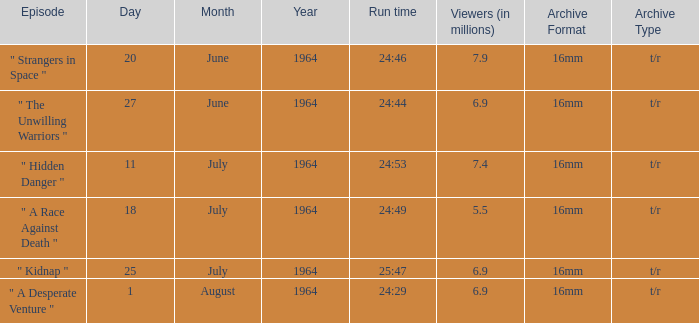Would you mind parsing the complete table? {'header': ['Episode', 'Day', 'Month', 'Year', 'Run time', 'Viewers (in millions)', 'Archive Format', 'Archive Type'], 'rows': [['" Strangers in Space "', '20', 'June', '1964', '24:46', '7.9', '16mm', 't/r'], ['" The Unwilling Warriors "', '27', 'June', '1964', '24:44', '6.9', '16mm', 't/r'], ['" Hidden Danger "', '11', 'July', '1964', '24:53', '7.4', '16mm', 't/r'], ['" A Race Against Death "', '18', 'July', '1964', '24:49', '5.5', '16mm', 't/r'], ['" Kidnap "', '25', 'July', '1964', '25:47', '6.9', '16mm', 't/r'], ['" A Desperate Venture "', '1', 'August', '1964', '24:29', '6.9', '16mm', 't/r']]} What is run time when there were 7.4 million viewers? 24:53. 